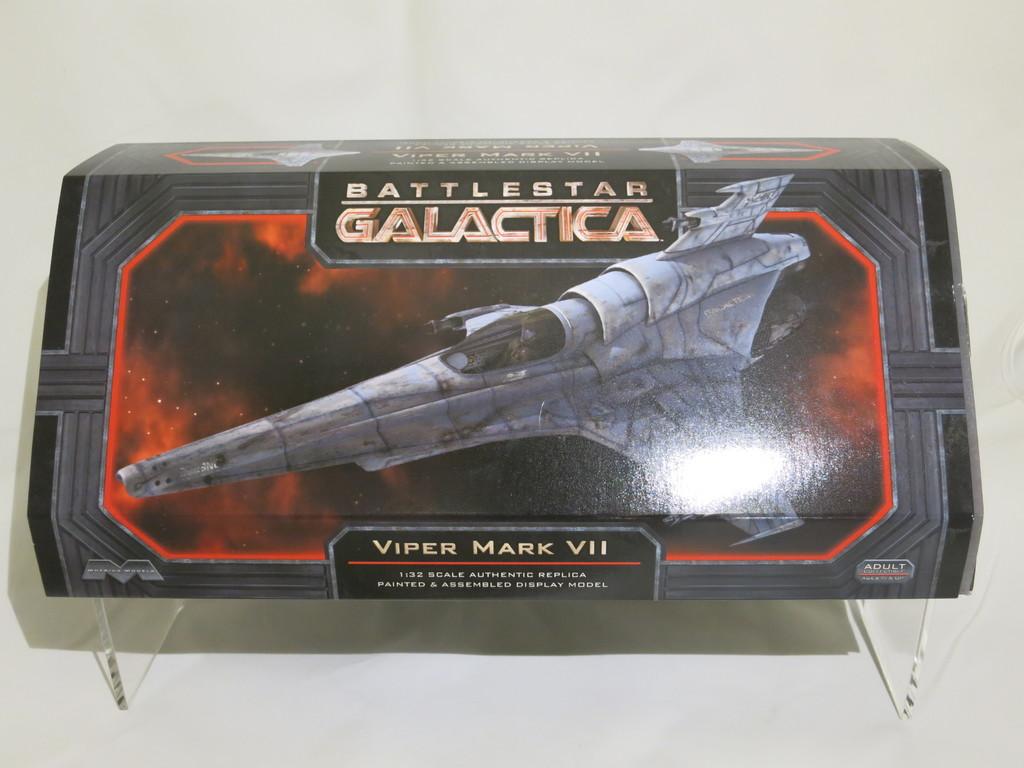Which battlestar series is this from?
Your answer should be compact. Galactica. What type of space ship is shown?
Offer a very short reply. Viper mark vii. 